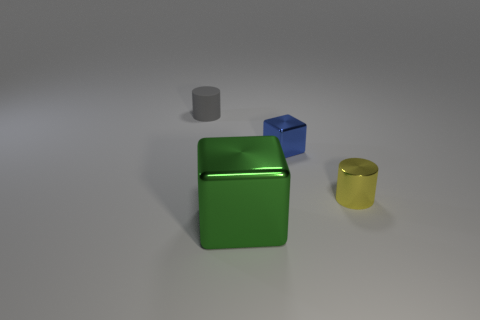What materials do the objects in the image appear to be made of? The objects in the image seem to have a shiny surface, suggesting they could be made of materials like polished metal or plastic with a metallic paint finish. 